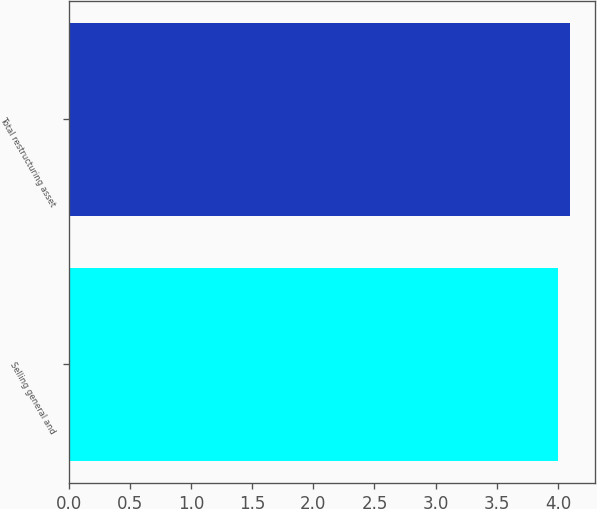Convert chart to OTSL. <chart><loc_0><loc_0><loc_500><loc_500><bar_chart><fcel>Selling general and<fcel>Total restructuring asset<nl><fcel>4<fcel>4.1<nl></chart> 